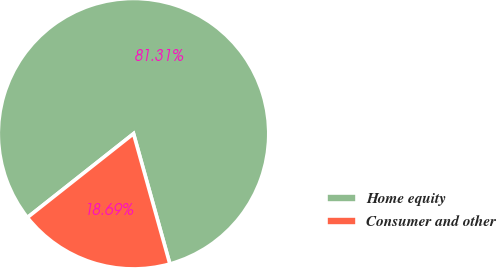Convert chart. <chart><loc_0><loc_0><loc_500><loc_500><pie_chart><fcel>Home equity<fcel>Consumer and other<nl><fcel>81.31%<fcel>18.69%<nl></chart> 